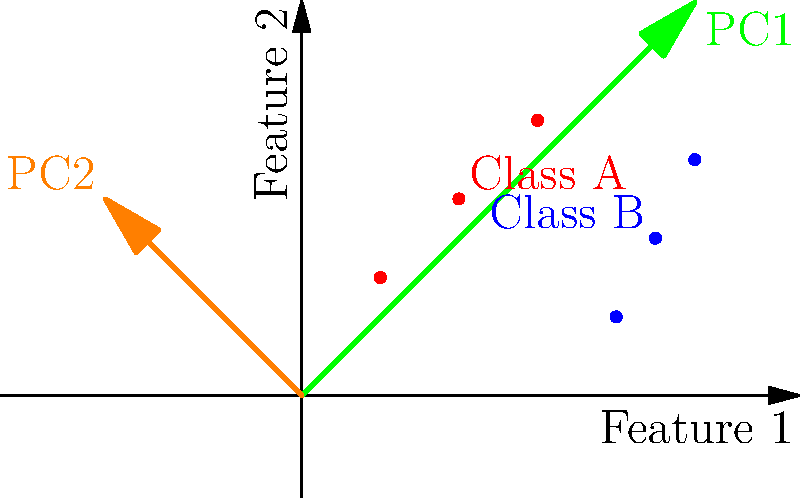In the context of facial recognition using Principal Component Analysis (PCA), the graph shows a 2D projection of facial features for two classes. Given that the green arrow represents the first principal component (PC1) and the orange arrow represents the second principal component (PC2), which of the following statements is true?

A) PC1 maximizes the variance between classes
B) PC2 captures more variance than PC1
C) The classes are perfectly separable in this 2D space
D) PC1 and PC2 are orthogonal to each other Let's analyze this step-by-step:

1) Principal Component Analysis (PCA) is a dimensionality reduction technique that finds the directions (principal components) of maximum variance in the dataset.

2) The first principal component (PC1, green arrow) always captures the direction of maximum variance in the data. This is evident from the graph as PC1 aligns with the overall spread of the data points.

3) The second principal component (PC2, orange arrow) is orthogonal to PC1 and captures the second-highest variance in the data.

4) In facial recognition, PCA is often used to reduce the dimensionality of face images, with each principal component representing an "eigenface".

5) Looking at the graph:
   - PC1 and PC2 are clearly perpendicular to each other, satisfying the orthogonality condition of PCA.
   - PC1 doesn't seem to maximize the separation between classes, as both classes have significant spread along PC1.
   - PC2 is shorter than PC1, indicating that it captures less variance.
   - The classes (red and blue points) overlap in this 2D space, so they are not perfectly separable.

6) Among the given options, only statement D is correct. PC1 and PC2 are indeed orthogonal to each other, which is a fundamental property of principal components.

Therefore, the correct answer is option D.
Answer: D) PC1 and PC2 are orthogonal to each other 